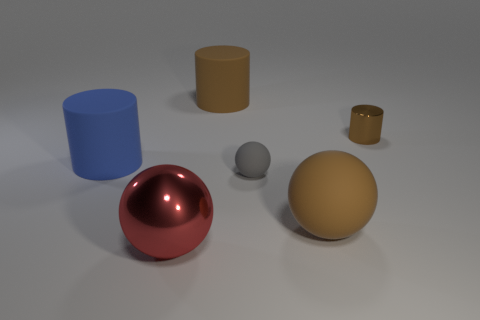Subtract all red cylinders. Subtract all gray balls. How many cylinders are left? 3 Add 1 metal balls. How many objects exist? 7 Subtract 0 green cubes. How many objects are left? 6 Subtract all small brown shiny cylinders. Subtract all big brown rubber balls. How many objects are left? 4 Add 6 blue things. How many blue things are left? 7 Add 2 gray objects. How many gray objects exist? 3 